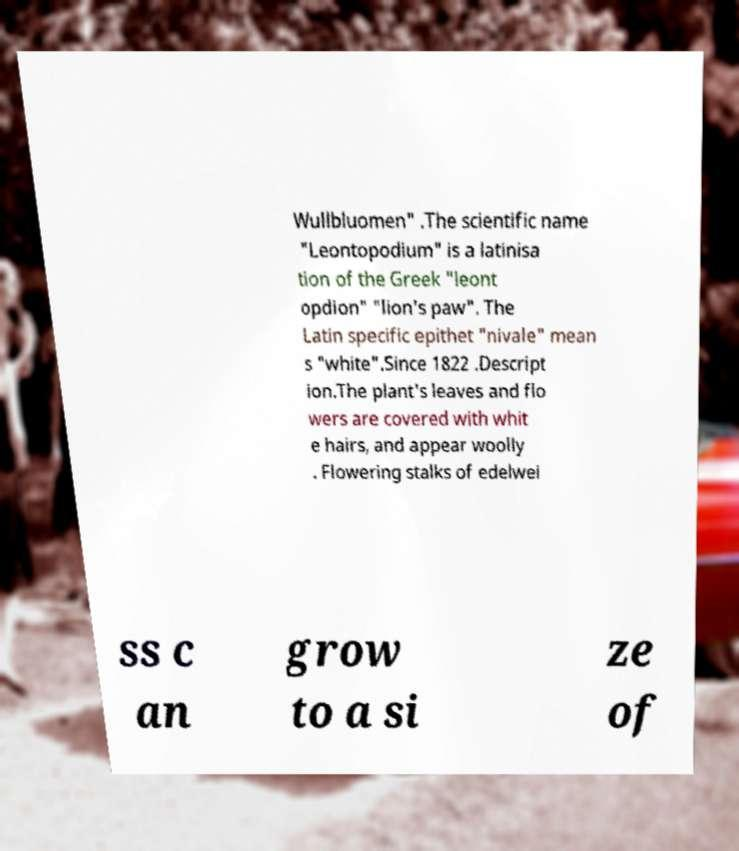Please identify and transcribe the text found in this image. Wullbluomen" .The scientific name "Leontopodium" is a latinisa tion of the Greek "leont opdion" "lion's paw". The Latin specific epithet "nivale" mean s "white".Since 1822 .Descript ion.The plant's leaves and flo wers are covered with whit e hairs, and appear woolly . Flowering stalks of edelwei ss c an grow to a si ze of 